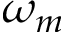<formula> <loc_0><loc_0><loc_500><loc_500>\omega _ { m }</formula> 